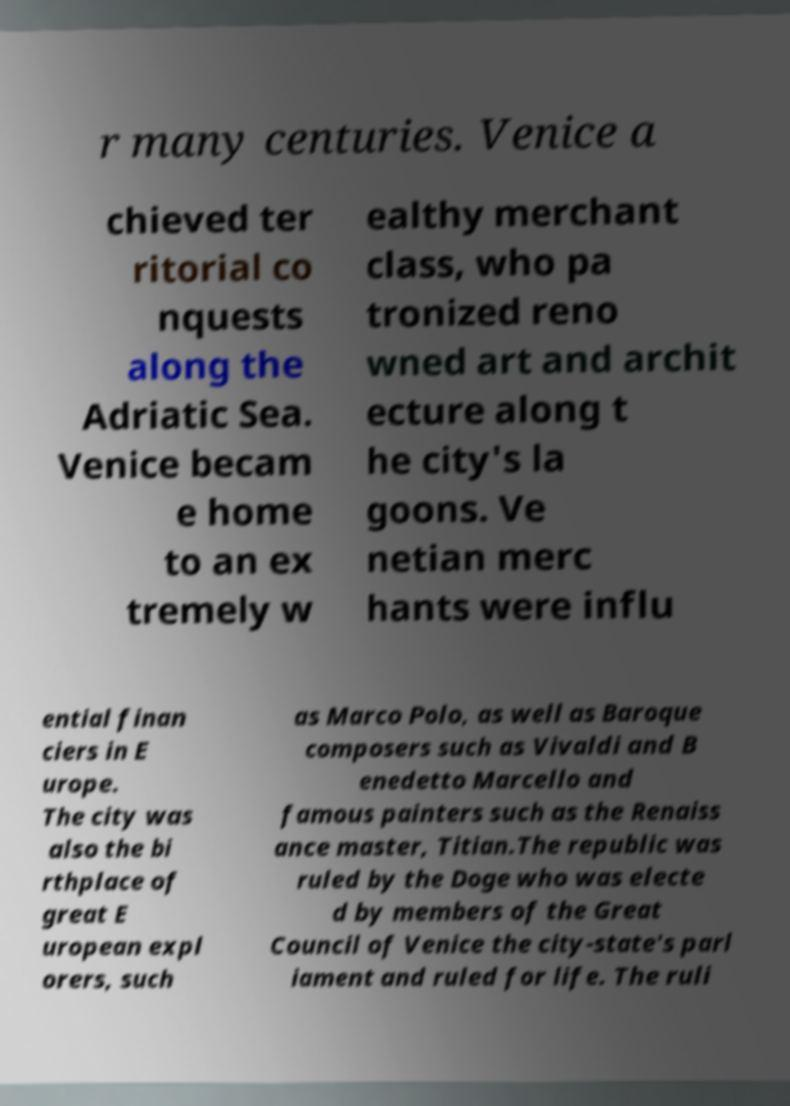For documentation purposes, I need the text within this image transcribed. Could you provide that? r many centuries. Venice a chieved ter ritorial co nquests along the Adriatic Sea. Venice becam e home to an ex tremely w ealthy merchant class, who pa tronized reno wned art and archit ecture along t he city's la goons. Ve netian merc hants were influ ential finan ciers in E urope. The city was also the bi rthplace of great E uropean expl orers, such as Marco Polo, as well as Baroque composers such as Vivaldi and B enedetto Marcello and famous painters such as the Renaiss ance master, Titian.The republic was ruled by the Doge who was electe d by members of the Great Council of Venice the city-state's parl iament and ruled for life. The ruli 